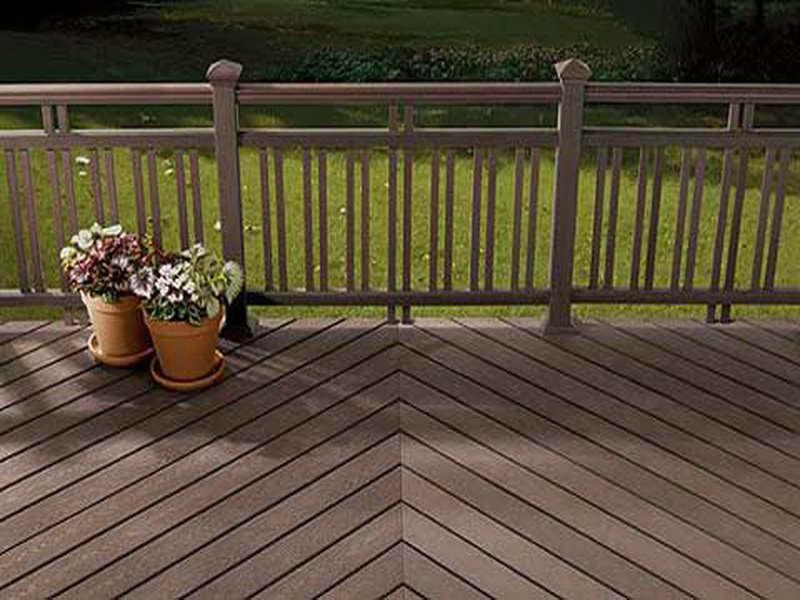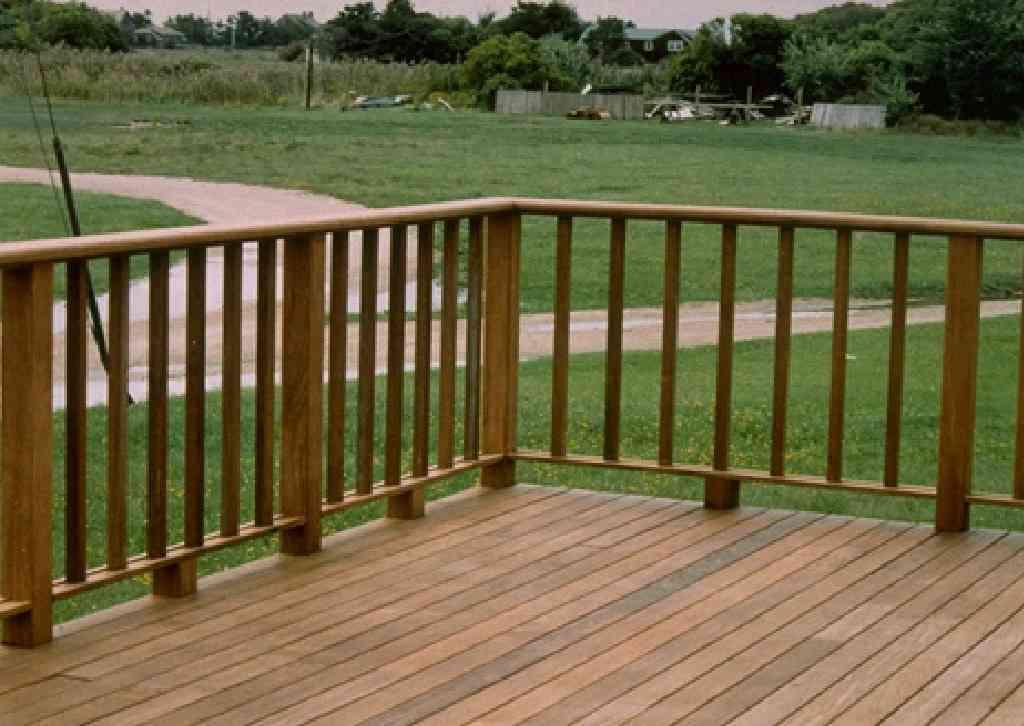The first image is the image on the left, the second image is the image on the right. For the images displayed, is the sentence "In one of the images, you can see a blacktop road in the background." factually correct? Answer yes or no. No. 